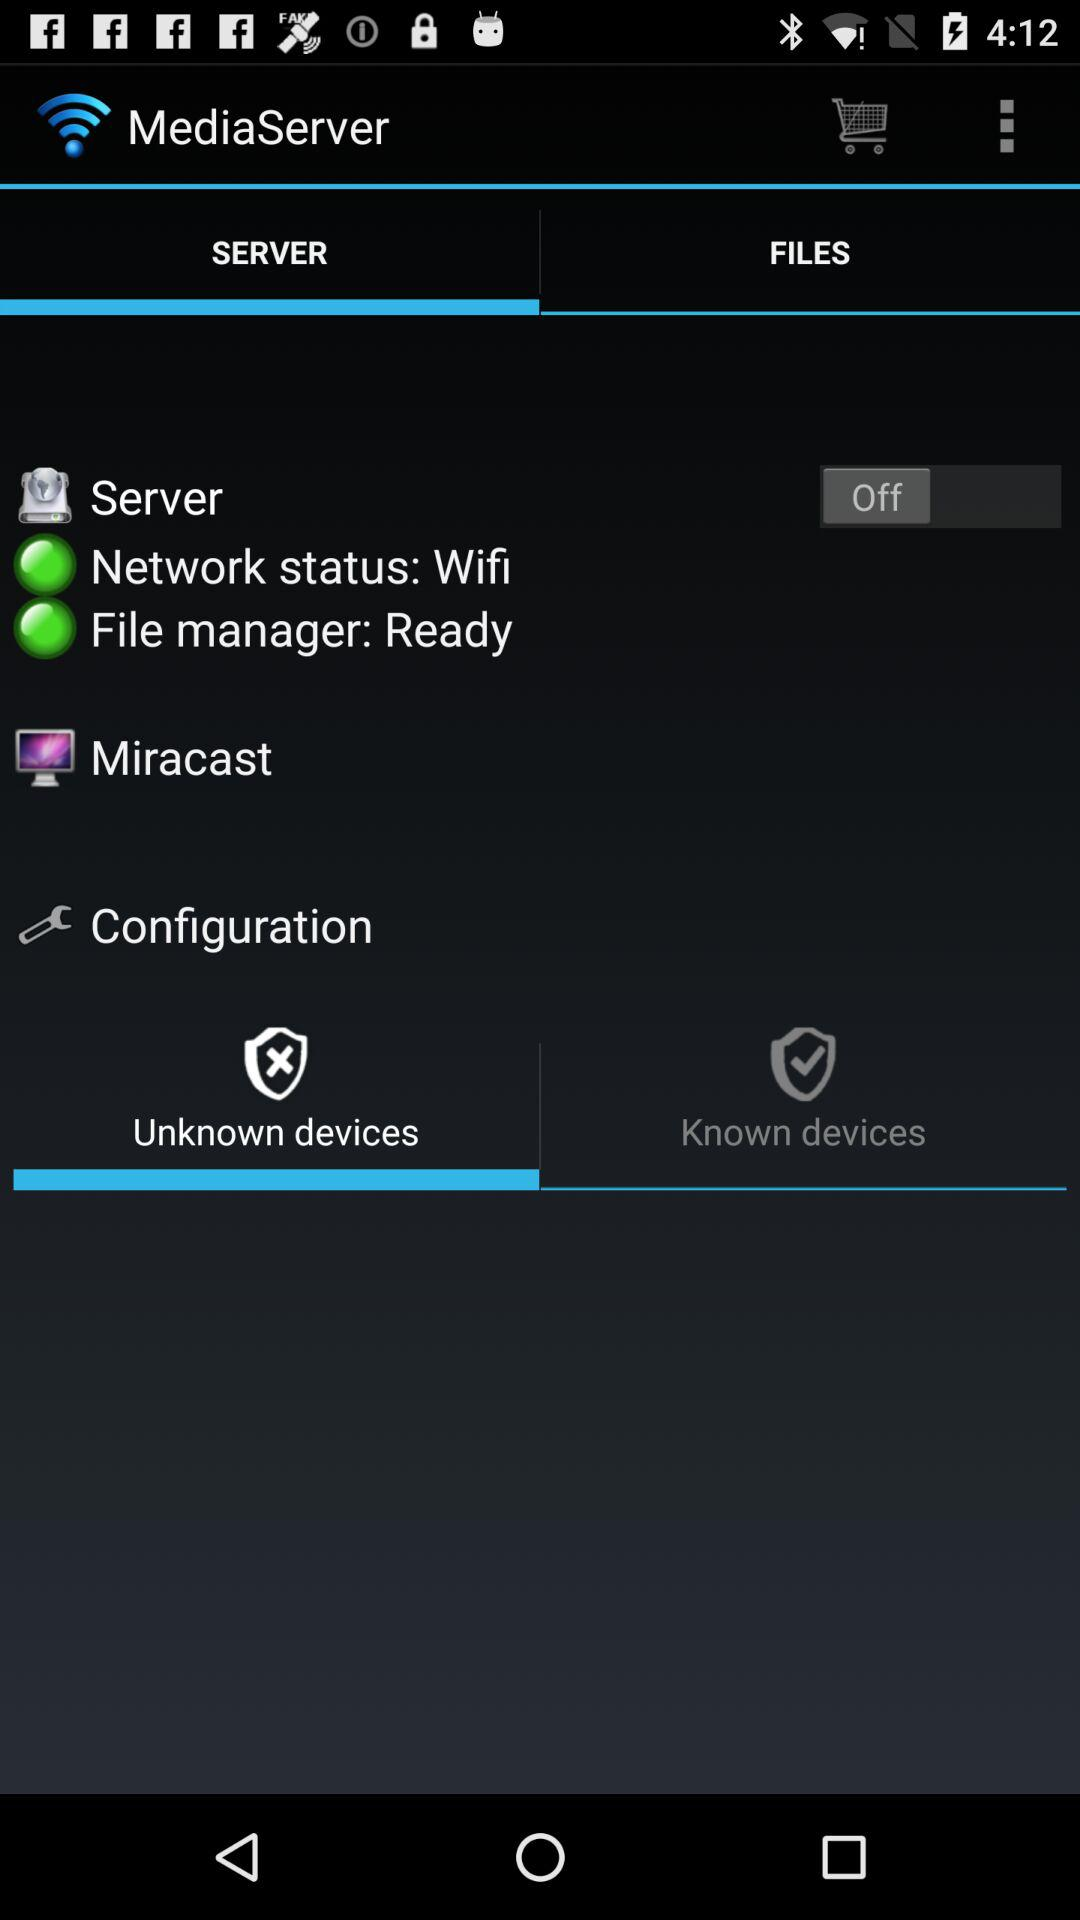Which tab is selected? The selected tab is "SERVER". 